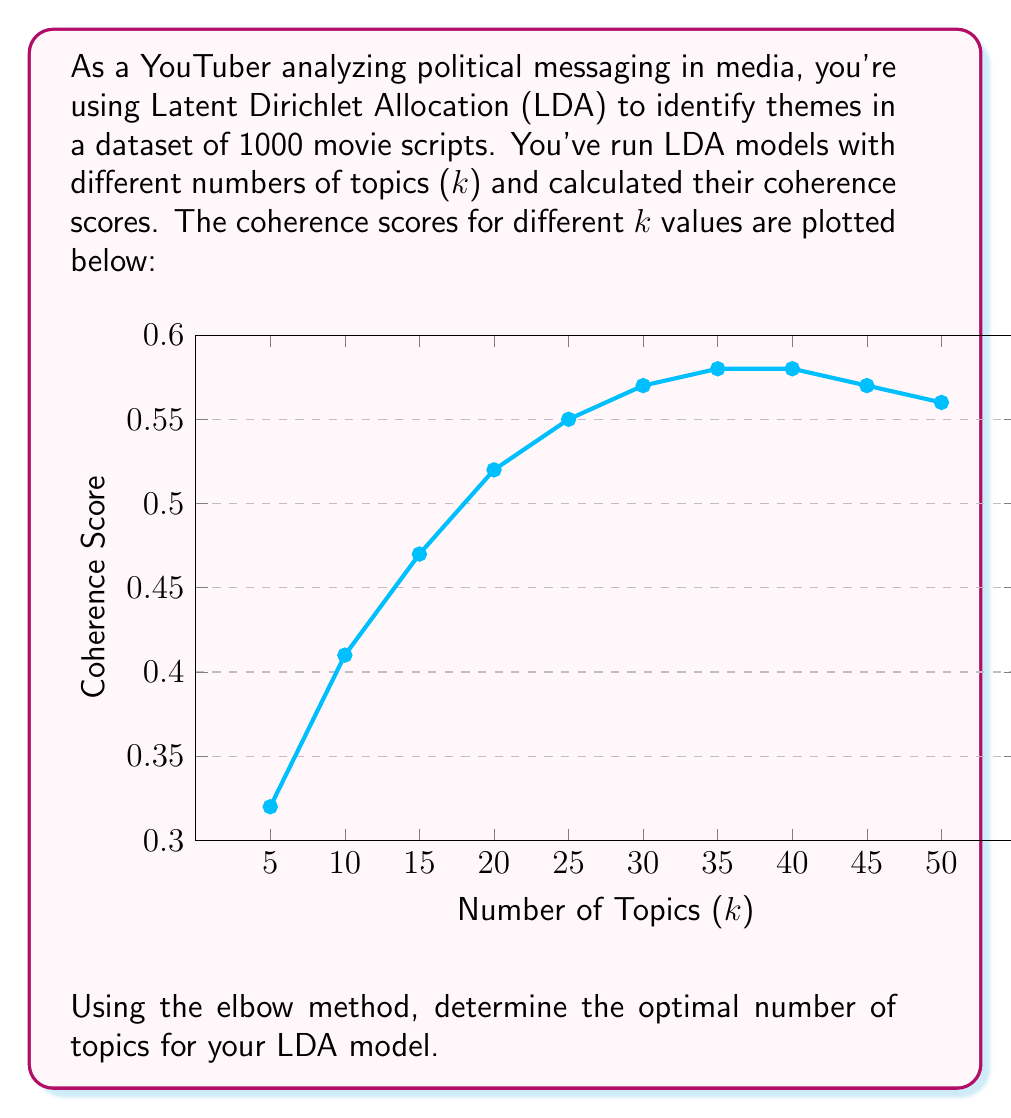Can you solve this math problem? To determine the optimal number of topics using the elbow method, we need to follow these steps:

1. Observe the coherence scores plotted against the number of topics (k).
2. Look for the point where the rate of increase in coherence score starts to level off, forming an "elbow" in the curve.
3. This point represents the optimal number of topics, as increasing k beyond this point yields diminishing returns in coherence.

Analyzing the graph:

1. We see a sharp increase in coherence score from k=5 to k=20.
2. The rate of increase slows down significantly after k=20.
3. The curve begins to plateau around k=30 to k=40.
4. After k=40, the coherence score starts to decrease slightly.

The "elbow" in this curve appears to be at k=30. This is where:
- The sharp increase in coherence score has leveled off.
- Further increases in k provide minimal improvements in coherence.
- It's before the point where adding more topics starts to decrease coherence.

Therefore, the optimal number of topics for this LDA model, based on the elbow method, is 30.
Answer: 30 topics 